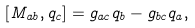<formula> <loc_0><loc_0><loc_500><loc_500>[ M _ { a b } , q _ { c } ] = g _ { a c } q _ { b } - g _ { b c } q _ { a } ,</formula> 